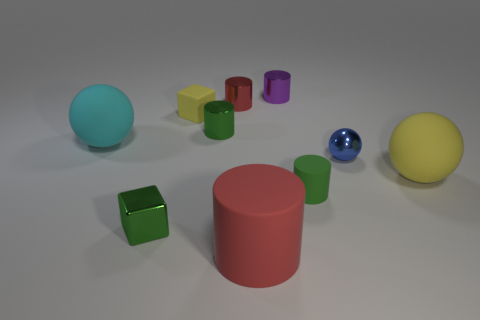Do the shiny cube and the small matte cylinder have the same color?
Offer a terse response. Yes. Is the tiny green object that is behind the large cyan thing made of the same material as the yellow object to the right of the rubber cube?
Keep it short and to the point. No. Is there a green cube of the same size as the green rubber cylinder?
Your answer should be compact. Yes. There is a metallic cylinder right of the red cylinder that is behind the tiny matte cube; what size is it?
Your answer should be very brief. Small. How many balls are the same color as the tiny rubber block?
Provide a short and direct response. 1. What is the shape of the thing that is left of the small block in front of the metallic sphere?
Offer a very short reply. Sphere. What number of small purple objects are made of the same material as the small red cylinder?
Your answer should be compact. 1. What material is the tiny cube in front of the tiny rubber block?
Ensure brevity in your answer.  Metal. There is a yellow thing on the right side of the green metallic cylinder to the left of the large ball in front of the cyan rubber thing; what is its shape?
Your response must be concise. Sphere. Does the cylinder that is to the left of the small red cylinder have the same color as the ball that is left of the small red thing?
Provide a short and direct response. No. 